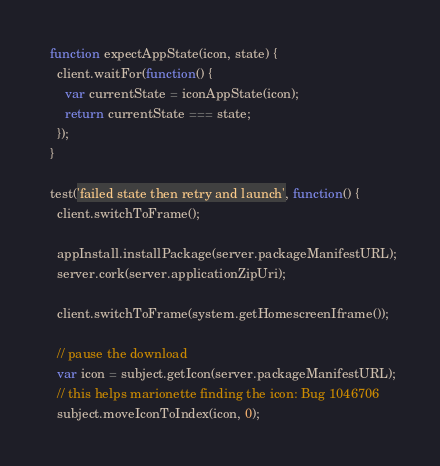<code> <loc_0><loc_0><loc_500><loc_500><_JavaScript_>
  function expectAppState(icon, state) {
    client.waitFor(function() {
      var currentState = iconAppState(icon);
      return currentState === state;
    });
  }

  test('failed state then retry and launch', function() {
    client.switchToFrame();

    appInstall.installPackage(server.packageManifestURL);
    server.cork(server.applicationZipUri);

    client.switchToFrame(system.getHomescreenIframe());

    // pause the download
    var icon = subject.getIcon(server.packageManifestURL);
    // this helps marionette finding the icon: Bug 1046706
    subject.moveIconToIndex(icon, 0);</code> 